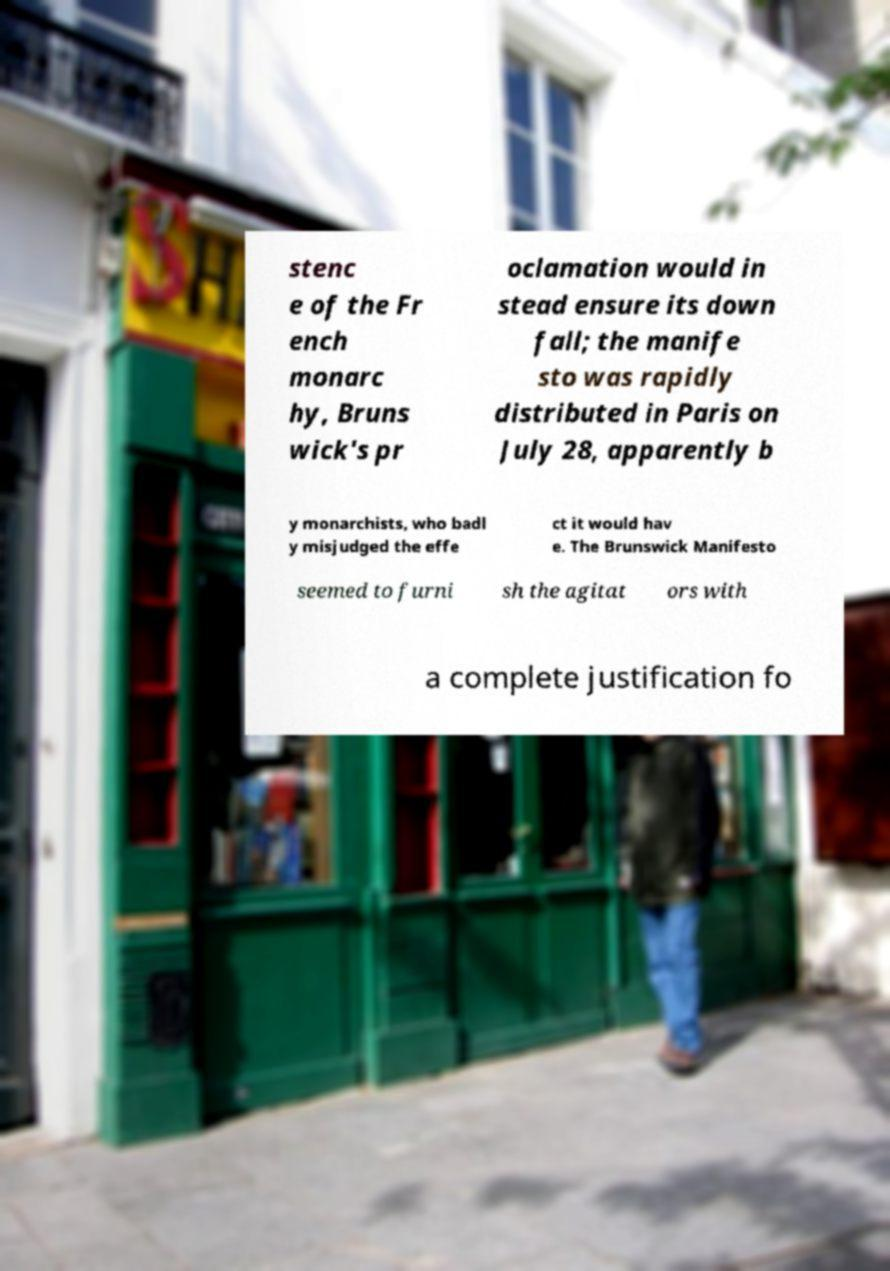There's text embedded in this image that I need extracted. Can you transcribe it verbatim? stenc e of the Fr ench monarc hy, Bruns wick's pr oclamation would in stead ensure its down fall; the manife sto was rapidly distributed in Paris on July 28, apparently b y monarchists, who badl y misjudged the effe ct it would hav e. The Brunswick Manifesto seemed to furni sh the agitat ors with a complete justification fo 